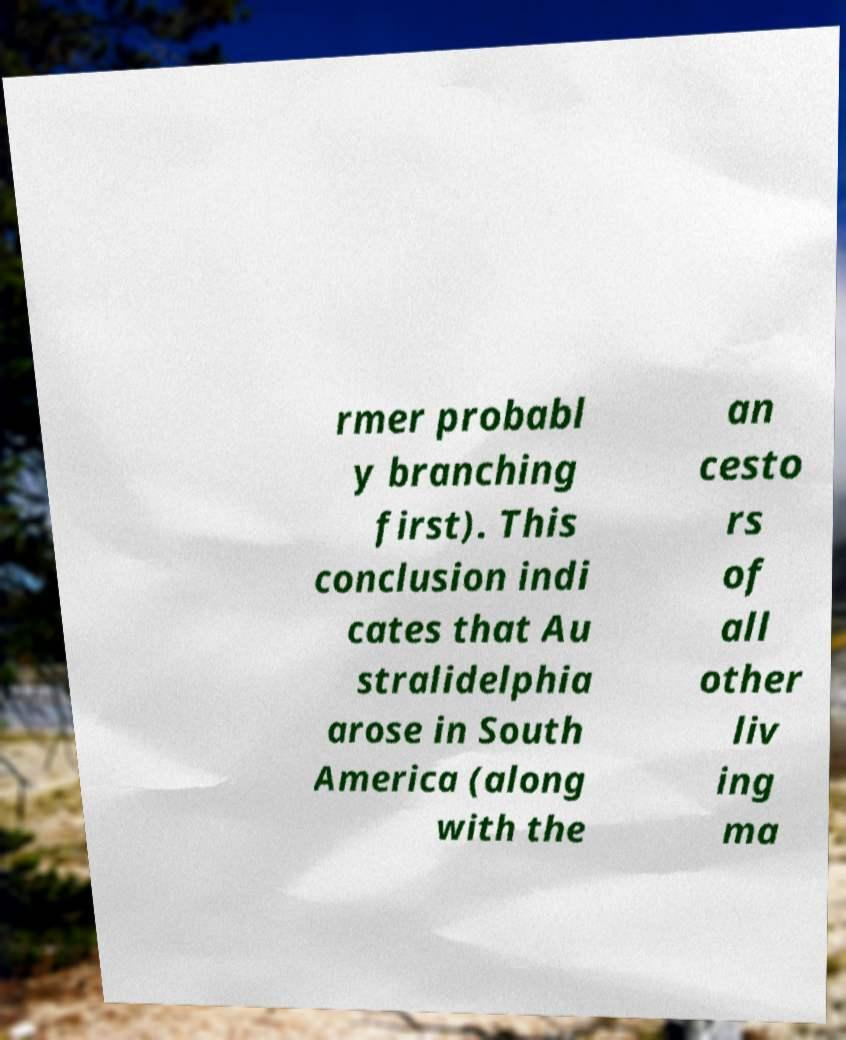Please identify and transcribe the text found in this image. rmer probabl y branching first). This conclusion indi cates that Au stralidelphia arose in South America (along with the an cesto rs of all other liv ing ma 